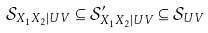Convert formula to latex. <formula><loc_0><loc_0><loc_500><loc_500>\mathcal { S } _ { X _ { 1 } X _ { 2 } | U V } \subseteq \mathcal { S } _ { X _ { 1 } X _ { 2 } | U V } ^ { \prime } \subseteq \mathcal { S } _ { U V }</formula> 